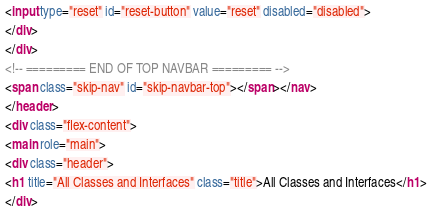Convert code to text. <code><loc_0><loc_0><loc_500><loc_500><_HTML_><input type="reset" id="reset-button" value="reset" disabled="disabled">
</div>
</div>
<!-- ========= END OF TOP NAVBAR ========= -->
<span class="skip-nav" id="skip-navbar-top"></span></nav>
</header>
<div class="flex-content">
<main role="main">
<div class="header">
<h1 title="All Classes and Interfaces" class="title">All Classes and Interfaces</h1>
</div></code> 